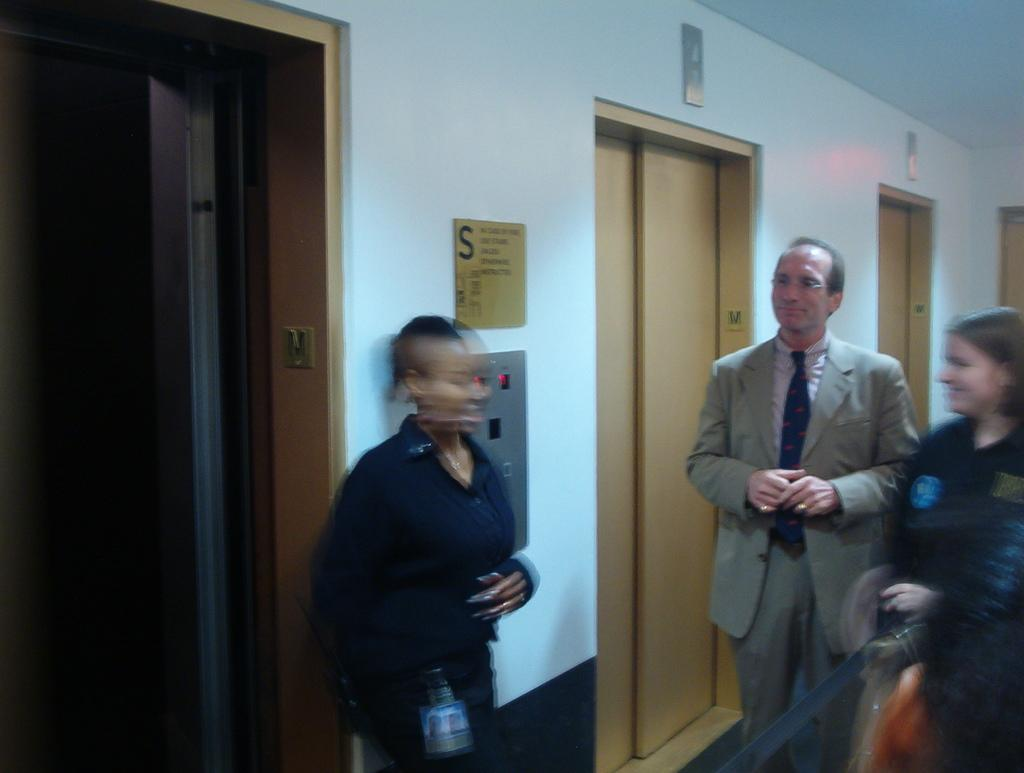Where was the image taken? The image was taken in a lobby. What can be seen in the lobby? There are people standing in the lobby, as well as walls, elevators, and boards. What type of structure might the elevators be part of? The elevators suggest that the lobby is part of a multi-story building. What might the boards be used for in the lobby? The boards could be used for displaying information, advertisements, or directions. What is the price of the chin visible in the image? There is no chin present in the image, and therefore no price can be determined. 